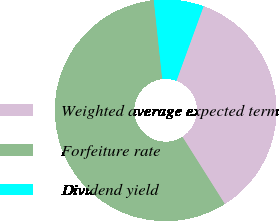Convert chart. <chart><loc_0><loc_0><loc_500><loc_500><pie_chart><fcel>Weighted average expected term<fcel>Forfeiture rate<fcel>Dividend yield<nl><fcel>35.48%<fcel>57.26%<fcel>7.26%<nl></chart> 